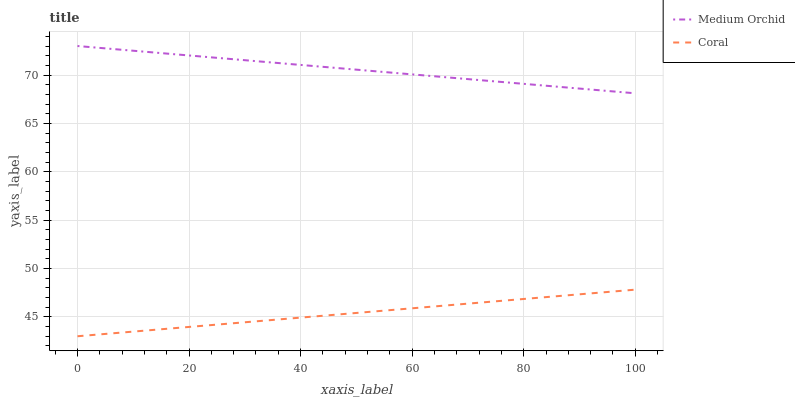Does Medium Orchid have the minimum area under the curve?
Answer yes or no. No. Is Medium Orchid the smoothest?
Answer yes or no. No. Does Medium Orchid have the lowest value?
Answer yes or no. No. Is Coral less than Medium Orchid?
Answer yes or no. Yes. Is Medium Orchid greater than Coral?
Answer yes or no. Yes. Does Coral intersect Medium Orchid?
Answer yes or no. No. 